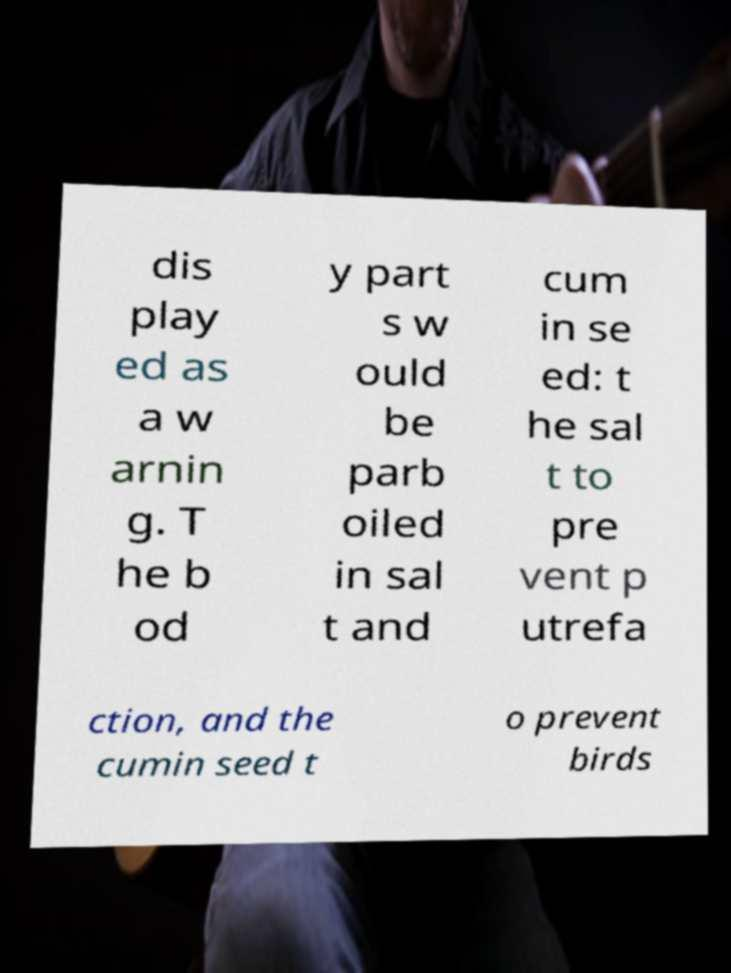Can you accurately transcribe the text from the provided image for me? dis play ed as a w arnin g. T he b od y part s w ould be parb oiled in sal t and cum in se ed: t he sal t to pre vent p utrefa ction, and the cumin seed t o prevent birds 